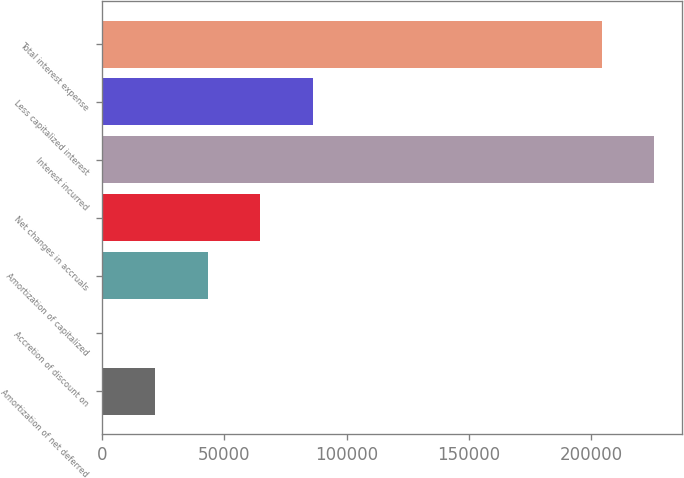<chart> <loc_0><loc_0><loc_500><loc_500><bar_chart><fcel>Amortization of net deferred<fcel>Accretion of discount on<fcel>Amortization of capitalized<fcel>Net changes in accruals<fcel>Interest incurred<fcel>Less capitalized interest<fcel>Total interest expense<nl><fcel>21738.3<fcel>257<fcel>43219.6<fcel>64700.9<fcel>225703<fcel>86182.2<fcel>204222<nl></chart> 